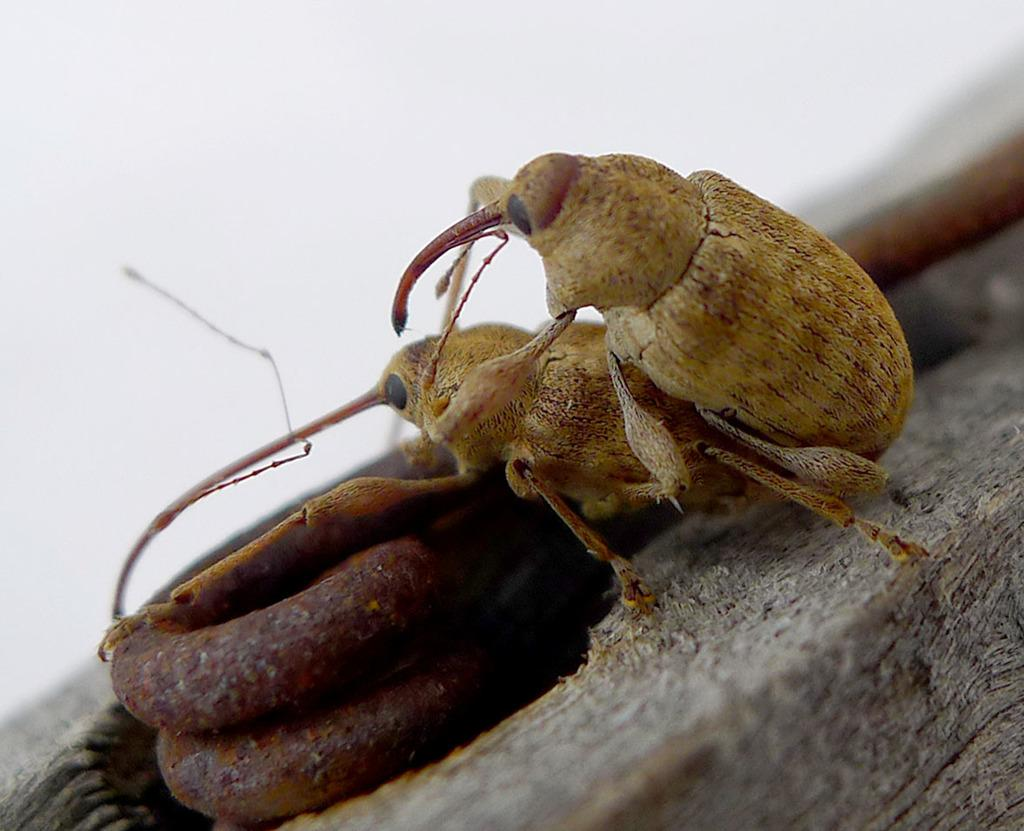What color is the background of the image? The background of the image is white. What can be seen on the surface in the image? There are insects on a surface in the image. What type of material is present with rust formation in the image? There is metal with rust formation in the image. How does the brush help with the insects' digestion in the image? There is no brush present in the image, and insects' digestion is not depicted or discussed. 